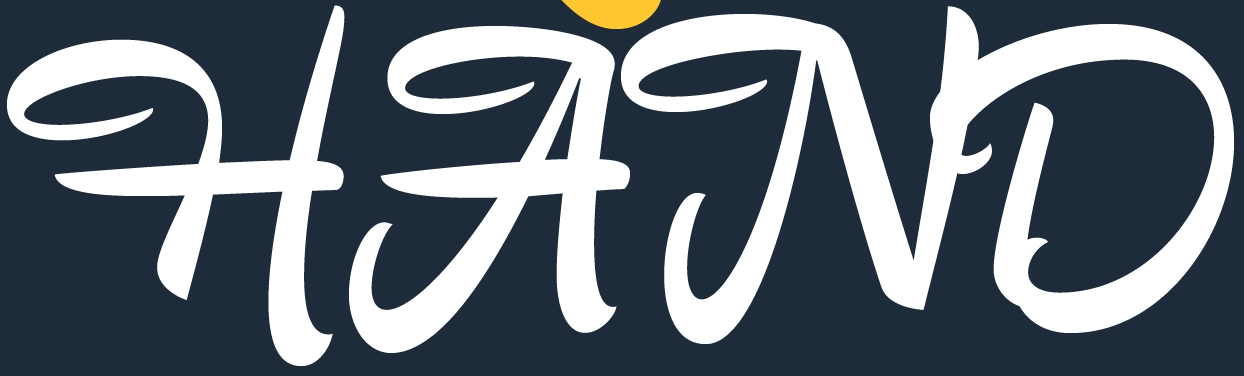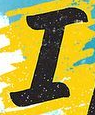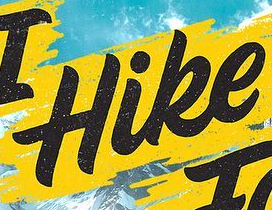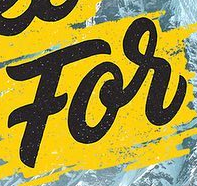What text appears in these images from left to right, separated by a semicolon? HAND; I; Hike; For 